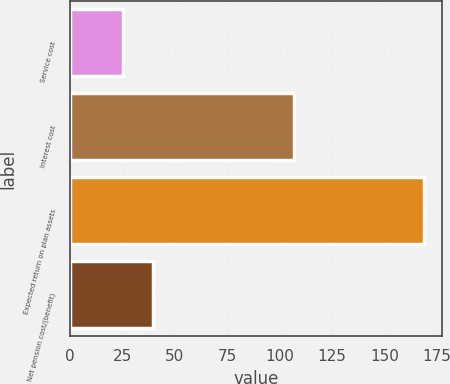Convert chart to OTSL. <chart><loc_0><loc_0><loc_500><loc_500><bar_chart><fcel>Service cost<fcel>Interest cost<fcel>Expected return on plan assets<fcel>Net pension cost/(benefit)<nl><fcel>25<fcel>107<fcel>169<fcel>39.4<nl></chart> 